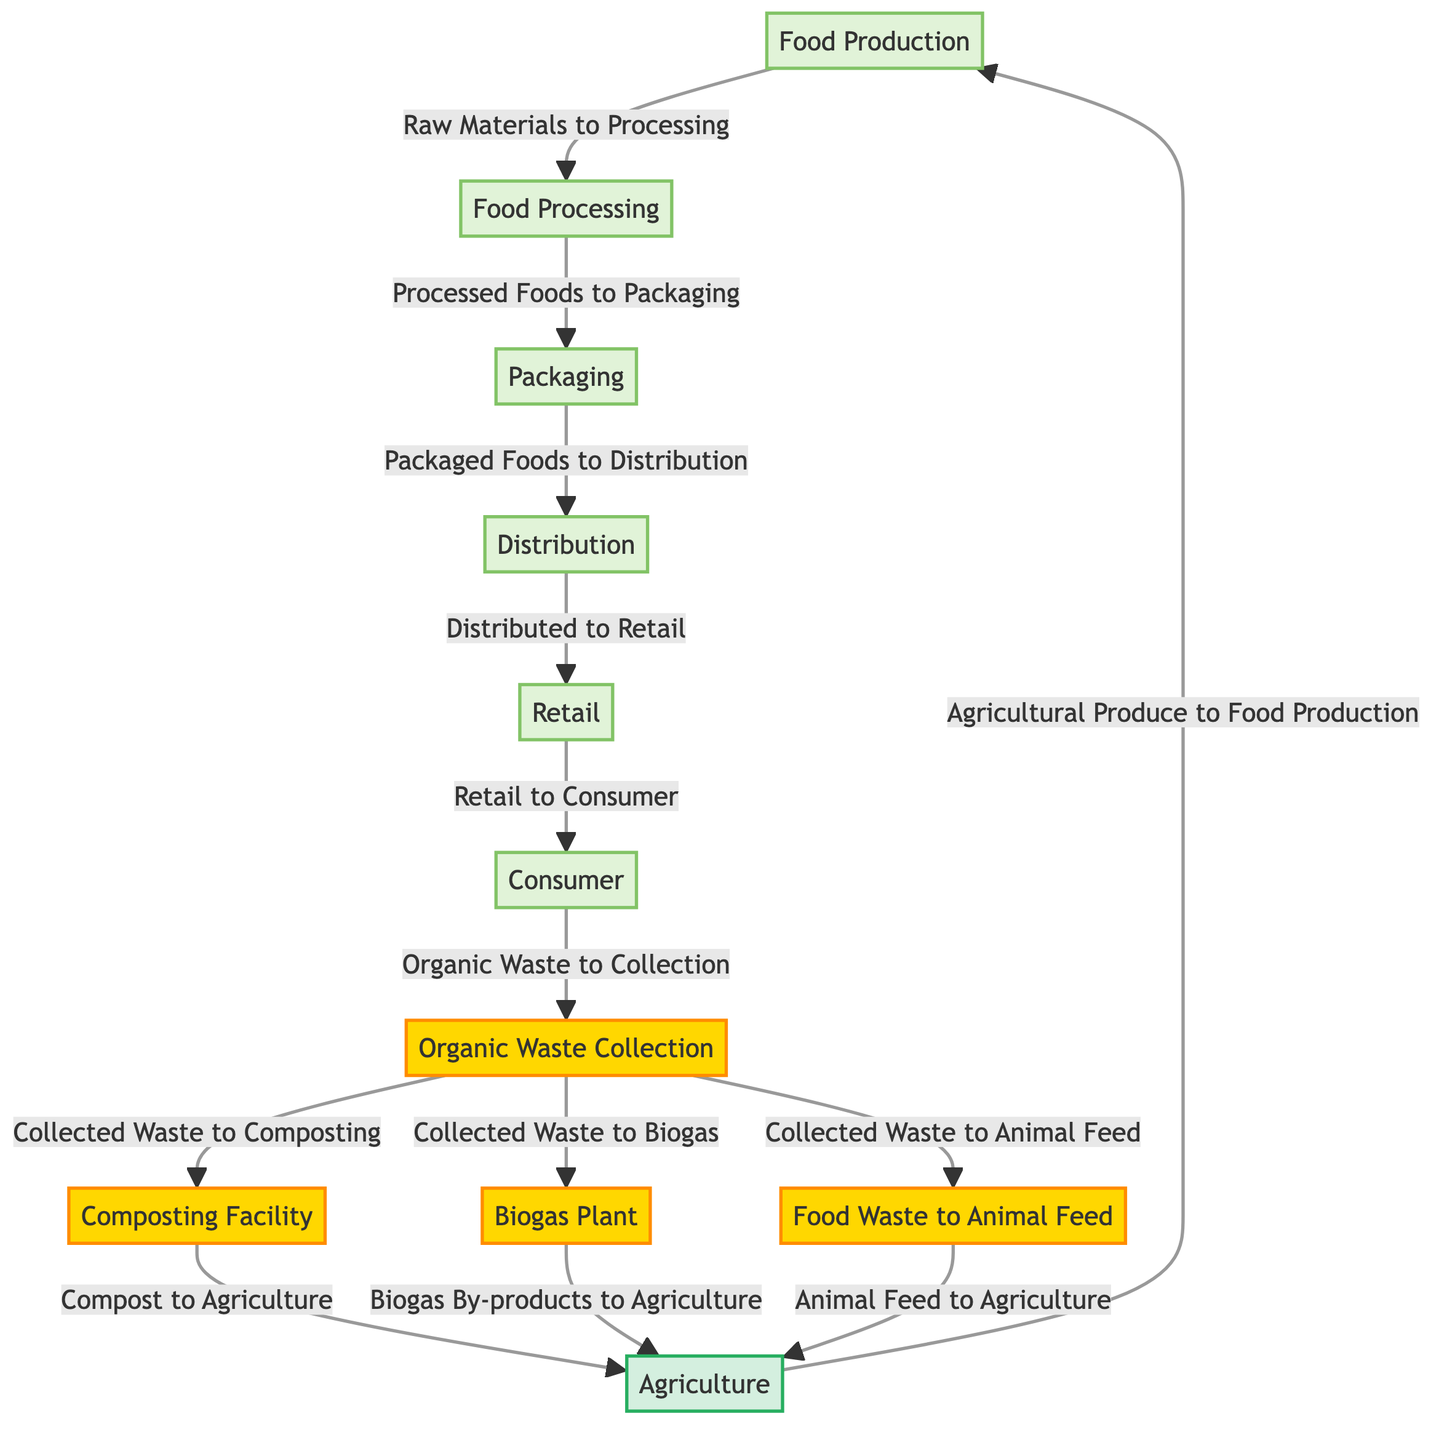What is the first node in the diagram? The first node in the diagram is Food Production, which is at the top of the flowchart and represents the beginning of the food chain.
Answer: Food Production How many processes are represented in the diagram? There are six processes indicated by the nodes: Food Production, Food Processing, Packaging, Distribution, Retail, and Consumer.
Answer: 6 What type of waste management follows organic waste collection? After organic waste collection, the diagram indicates that the organic waste can be sent to a Composting Facility, Biogas Plant, or Animal Feed, showcasing multiple options.
Answer: Composting Facility Which node is linked directly to the Food Production node? The Food Production node is directly linked to the Food Processing node, indicating it is the next step in the food chain.
Answer: Food Processing How many nodes are linked to the Organic Waste Collection node? The Organic Waste Collection node has three nodes linked to it: Composting Facility, Biogas Plant, and Animal Feed, indicating the ways to manage organic waste.
Answer: 3 What by-product is produced from the Biogas Plant? The Biogas Plant produces biogas by-products that are directed to Agriculture, showcasing how waste can be converted into useful resources.
Answer: Biogas By-products In what process does Compost eventually return to the food chain? Compost returns to the food chain through the Agriculture node, which utilizes the compost to contribute to food production again.
Answer: Agriculture What connections does Agriculture have in the diagram? Agriculture is connected to three nodes: it receives Compost, Biogas By-products, and Animal Feed, all of which contribute to agricultural production.
Answer: Compost, Biogas By-products, Animal Feed 